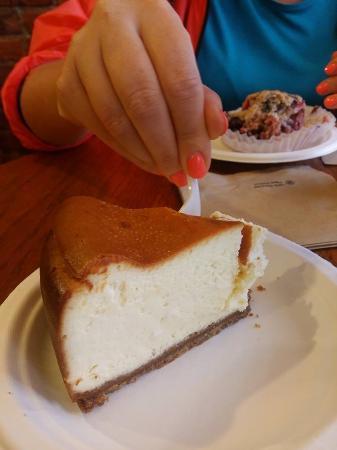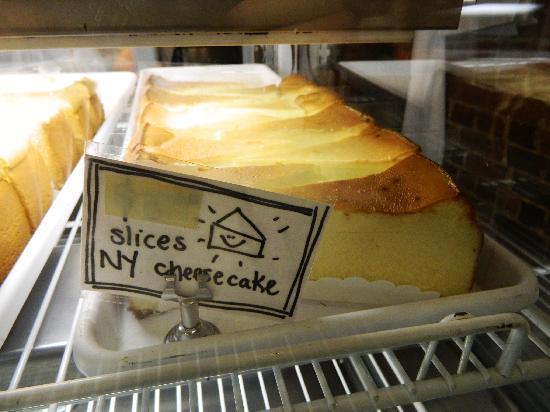The first image is the image on the left, the second image is the image on the right. Analyze the images presented: Is the assertion "There is a human hand reaching for a dessert." valid? Answer yes or no. Yes. 